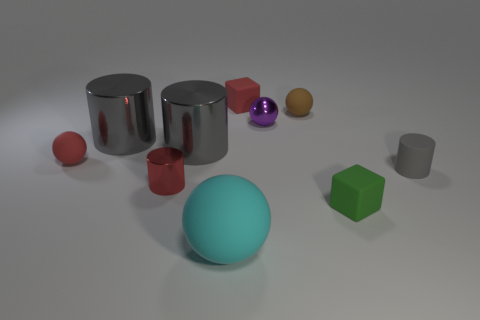Subtract all gray cylinders. How many were subtracted if there are1gray cylinders left? 2 Subtract all purple cubes. How many gray cylinders are left? 3 Subtract all spheres. How many objects are left? 6 Subtract all blue matte cylinders. Subtract all green cubes. How many objects are left? 9 Add 4 gray cylinders. How many gray cylinders are left? 7 Add 3 large yellow cylinders. How many large yellow cylinders exist? 3 Subtract 0 gray spheres. How many objects are left? 10 